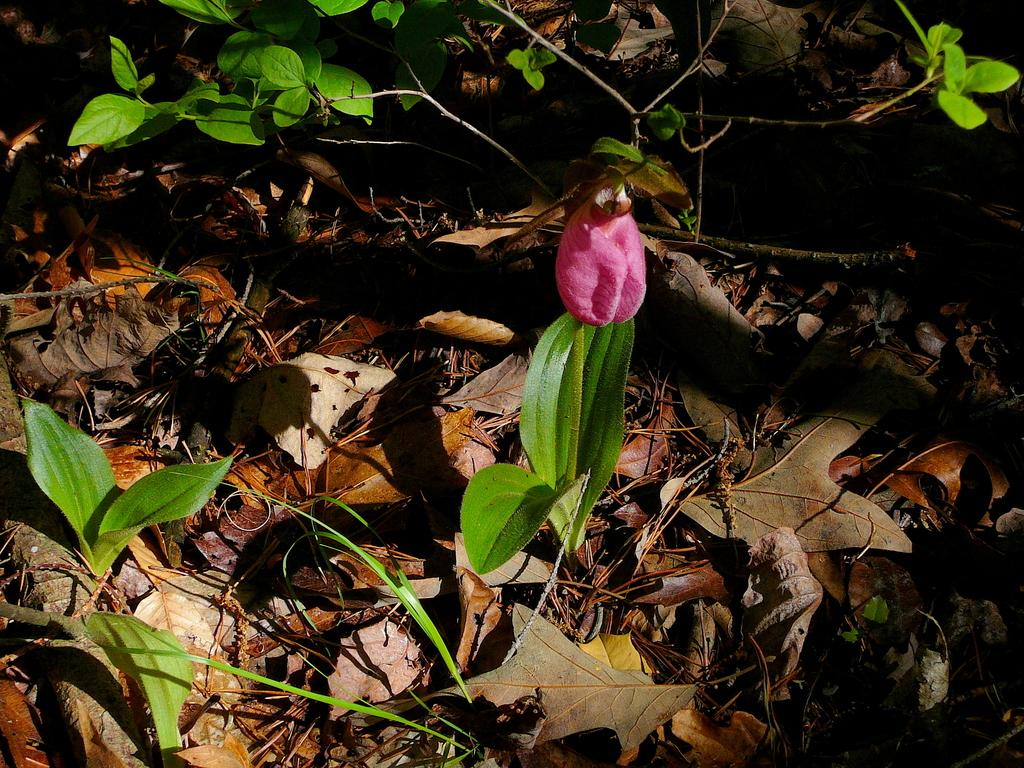What is the main subject in the center of the image? There is a plant in the center of the image, and it has a flower. What color is the flower in the center of the image? The flower is pink. What can be seen in the background of the image? There are plants and dry leaves in the background of the image, along with a few other objects. What type of business is being conducted in the image? There is no indication of any business being conducted in the image; it primarily features a plant with a pink flower and its background. 